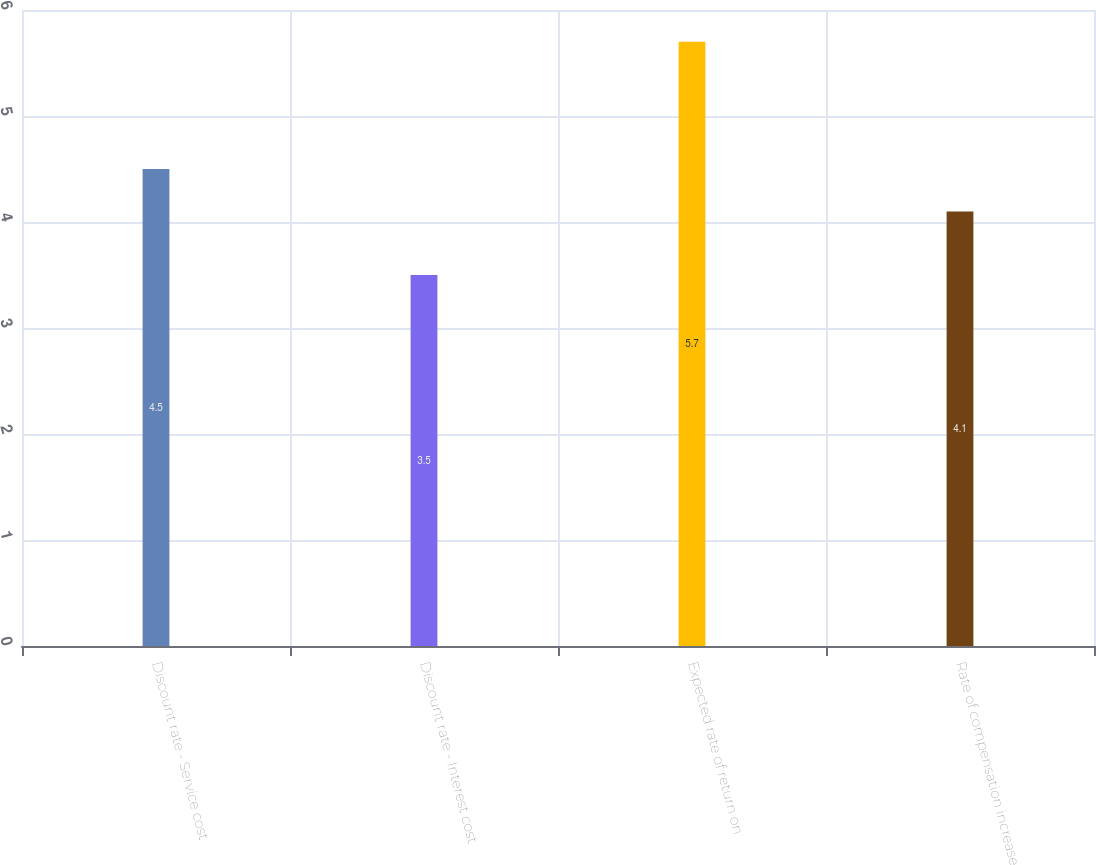Convert chart to OTSL. <chart><loc_0><loc_0><loc_500><loc_500><bar_chart><fcel>Discount rate - Service cost<fcel>Discount rate - Interest cost<fcel>Expected rate of return on<fcel>Rate of compensation increase<nl><fcel>4.5<fcel>3.5<fcel>5.7<fcel>4.1<nl></chart> 